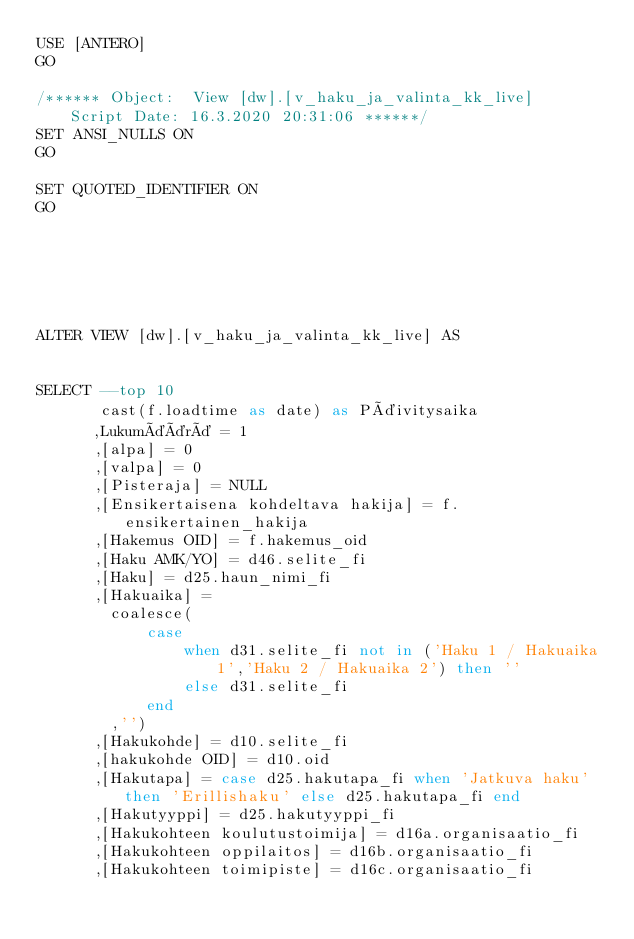Convert code to text. <code><loc_0><loc_0><loc_500><loc_500><_SQL_>USE [ANTERO]
GO

/****** Object:  View [dw].[v_haku_ja_valinta_kk_live]    Script Date: 16.3.2020 20:31:06 ******/
SET ANSI_NULLS ON
GO

SET QUOTED_IDENTIFIER ON
GO






ALTER VIEW [dw].[v_haku_ja_valinta_kk_live] AS


SELECT --top 10
	   cast(f.loadtime as date) as Päivitysaika
	  ,Lukumäärä = 1
	  ,[alpa] = 0
      ,[valpa] = 0
	  ,[Pisteraja] = NULL
	  ,[Ensikertaisena kohdeltava hakija] = f.ensikertainen_hakija	
	  ,[Hakemus OID] = f.hakemus_oid
	  ,[Haku AMK/YO] = d46.selite_fi
	  ,[Haku] = d25.haun_nimi_fi
	  ,[Hakuaika] = 
		coalesce(
			case 
				when d31.selite_fi not in ('Haku 1 / Hakuaika 1','Haku 2 / Hakuaika 2') then ''
				else d31.selite_fi 
			end
		,'')
	  ,[Hakukohde] = d10.selite_fi
	  ,[hakukohde OID] = d10.oid
	  ,[Hakutapa] = case d25.hakutapa_fi when 'Jatkuva haku' then 'Erillishaku' else d25.hakutapa_fi end
	  ,[Hakutyyppi] = d25.hakutyyppi_fi
	  ,[Hakukohteen koulutustoimija] = d16a.organisaatio_fi
	  ,[Hakukohteen oppilaitos] = d16b.organisaatio_fi
	  ,[Hakukohteen toimipiste] = d16c.organisaatio_fi</code> 